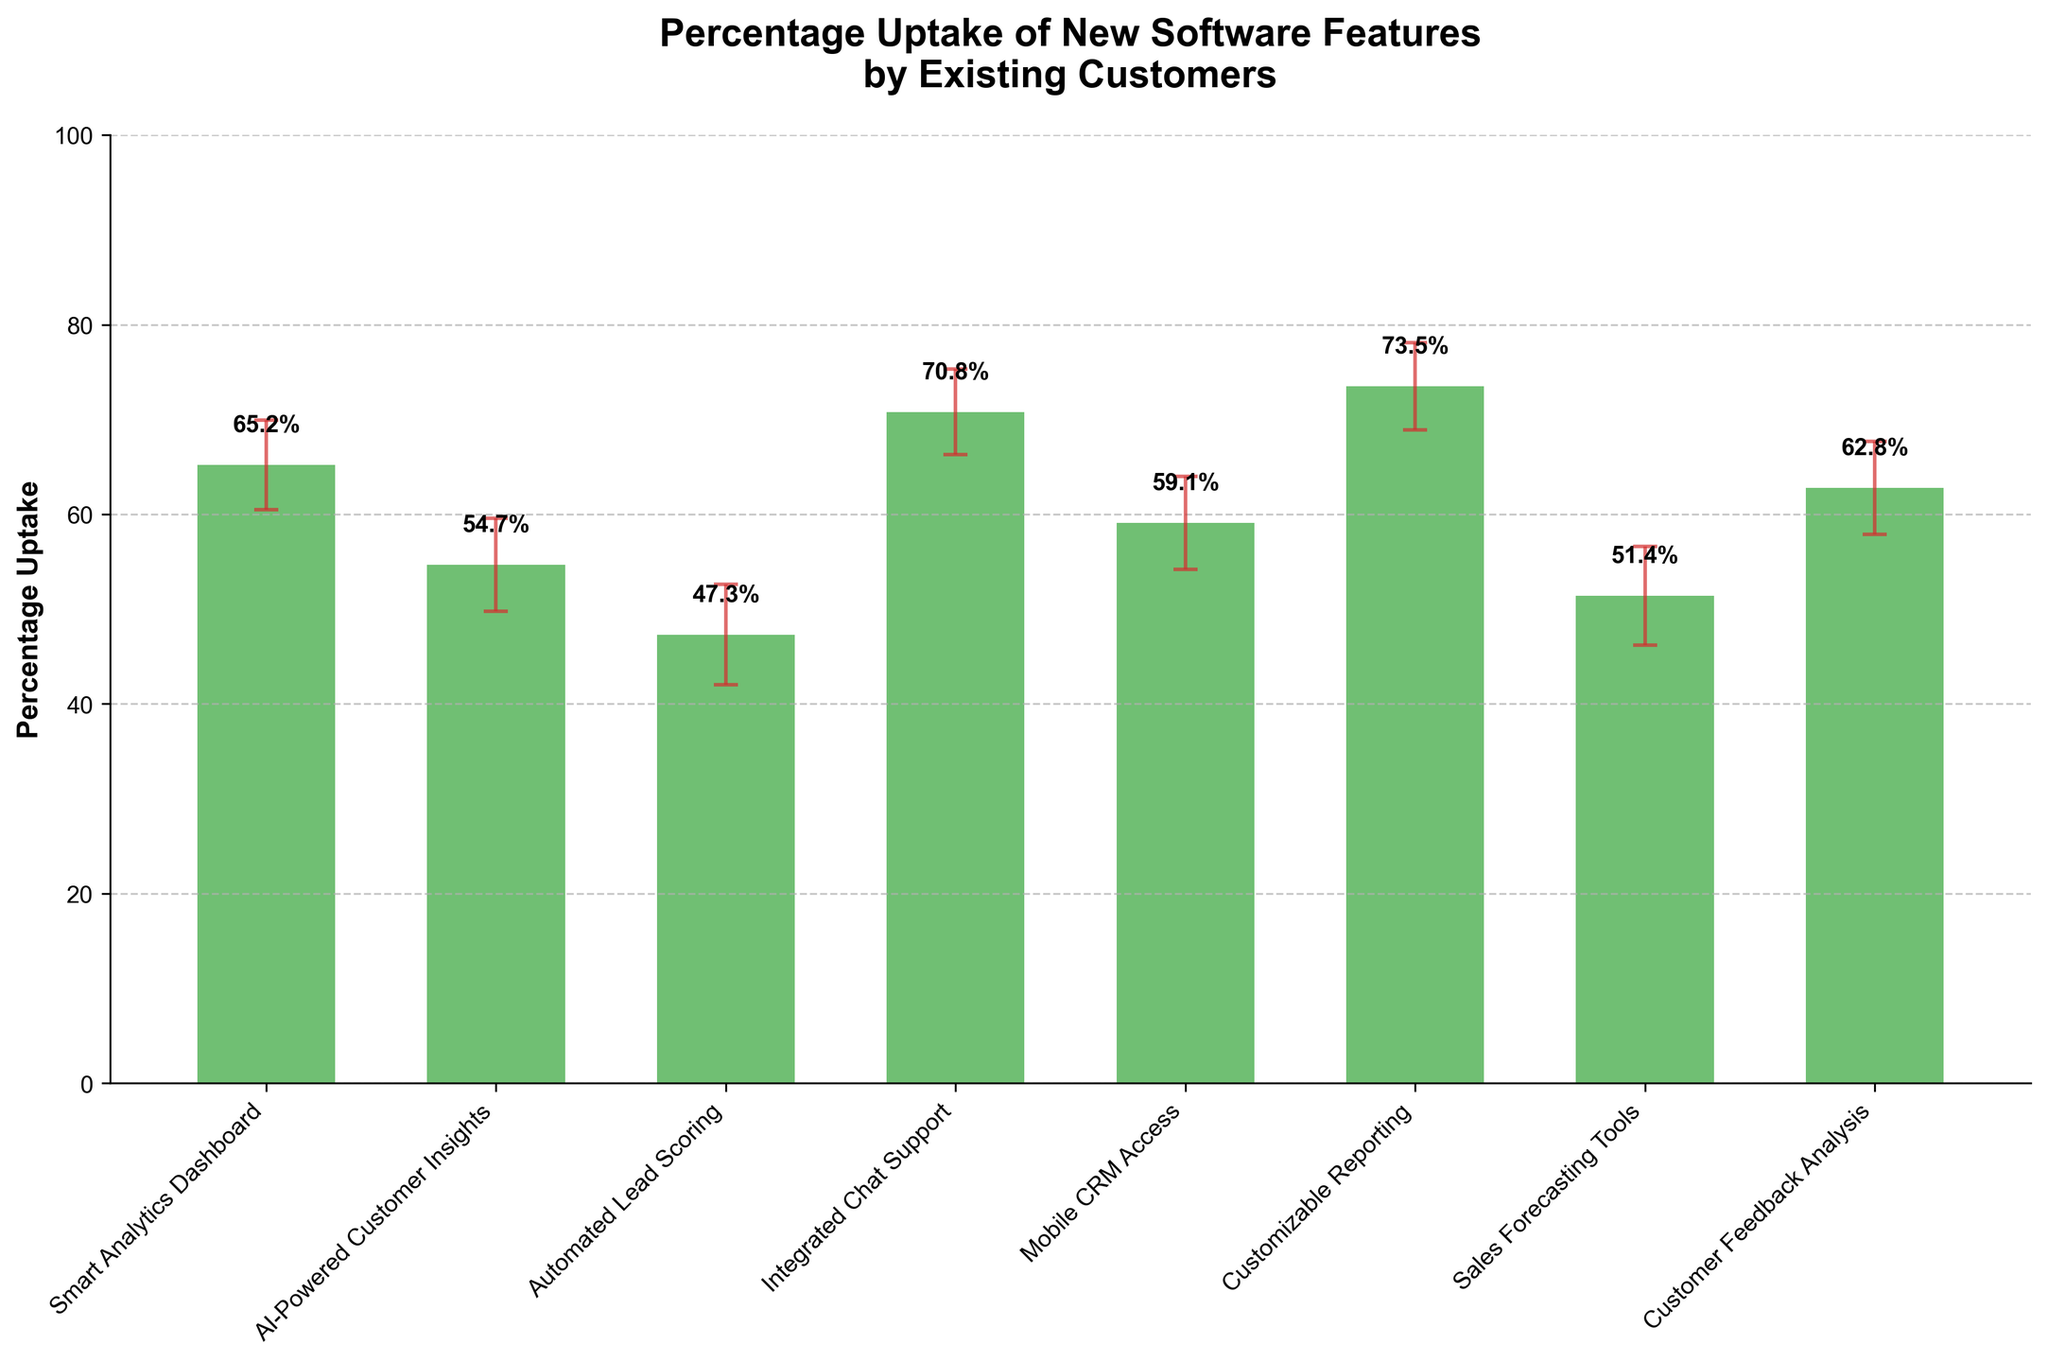What's the title of the chart? The title of the chart is placed at the top center of the figure and is labeled as "Percentage Uptake of New Software Features by Existing Customers."
Answer: Percentage Uptake of New Software Features by Existing Customers What's the highest percentage uptake observed, and for which feature? The highest percentage uptake is the tallest bar in the chart. It corresponds to the feature "Customizable Reporting" and has a value of 73.5%.
Answer: 73.5%, Customizable Reporting Which feature has the lowest upper confidence interval (CI) limit? To find the lowest upper CI, identify the smallest error bar endpoint among all features. "Automated Lead Scoring" has the lowest upper CI of 52.6%.
Answer: Automated Lead Scoring How many features have a percentage uptake greater than 60%? Features with percentage uptakes above 60% include "Smart Analytics Dashboard," "Integrated Chat Support," "Customizable Reporting," and "Customer Feedback Analysis." This counts to four features.
Answer: 4 Among "Mobile CRM Access" and "Sales Forecasting Tools," which has a higher percentage uptake? Compare the bars for "Mobile CRM Access" and "Sales Forecasting Tools." "Mobile CRM Access" has a higher uptake of 59.1% while "Sales Forecasting Tools" has 51.4%.
Answer: Mobile CRM Access What is the midpoint value between the lower and upper CI for "AI-Powered Customer Insights"? The midpoint is the average of the lower and upper CI values for "AI-Powered Customer Insights": (49.8 + 59.6) / 2 = 54.7%.
Answer: 54.7% What's the difference in percentage uptake between the features with the highest and lowest uptake? Subtract the lowest uptake value ("Automated Lead Scoring" at 47.3%) from the highest uptake value ("Customizable Reporting" at 73.5%): 73.5% - 47.3% = 26.2%.
Answer: 26.2% Which two features have the smallest error bars indicating the confidence intervals? The size of the error bars can be determined by the difference between upper and lower CI limits. "Customizable Reporting" (78.1% - 68.9% = 9.2%) and "AI-Powered Customer Insights" (59.6% - 49.8% = 9.8%) have the smallest error bars.
Answer: Customizable Reporting, AI-Powered Customer Insights 